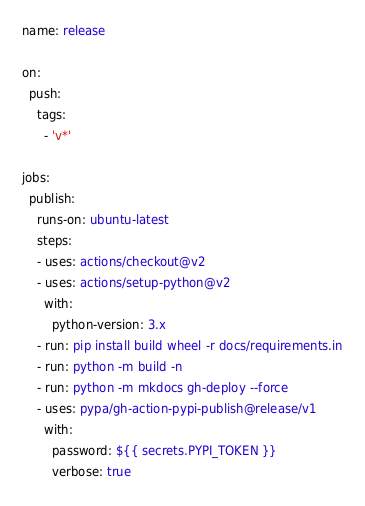<code> <loc_0><loc_0><loc_500><loc_500><_YAML_>name: release

on:
  push:
    tags:
      - 'v*'

jobs:
  publish:
    runs-on: ubuntu-latest
    steps:
    - uses: actions/checkout@v2
    - uses: actions/setup-python@v2
      with:
        python-version: 3.x
    - run: pip install build wheel -r docs/requirements.in
    - run: python -m build -n
    - run: python -m mkdocs gh-deploy --force
    - uses: pypa/gh-action-pypi-publish@release/v1
      with:
        password: ${{ secrets.PYPI_TOKEN }}
        verbose: true
</code> 